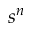Convert formula to latex. <formula><loc_0><loc_0><loc_500><loc_500>s ^ { n }</formula> 